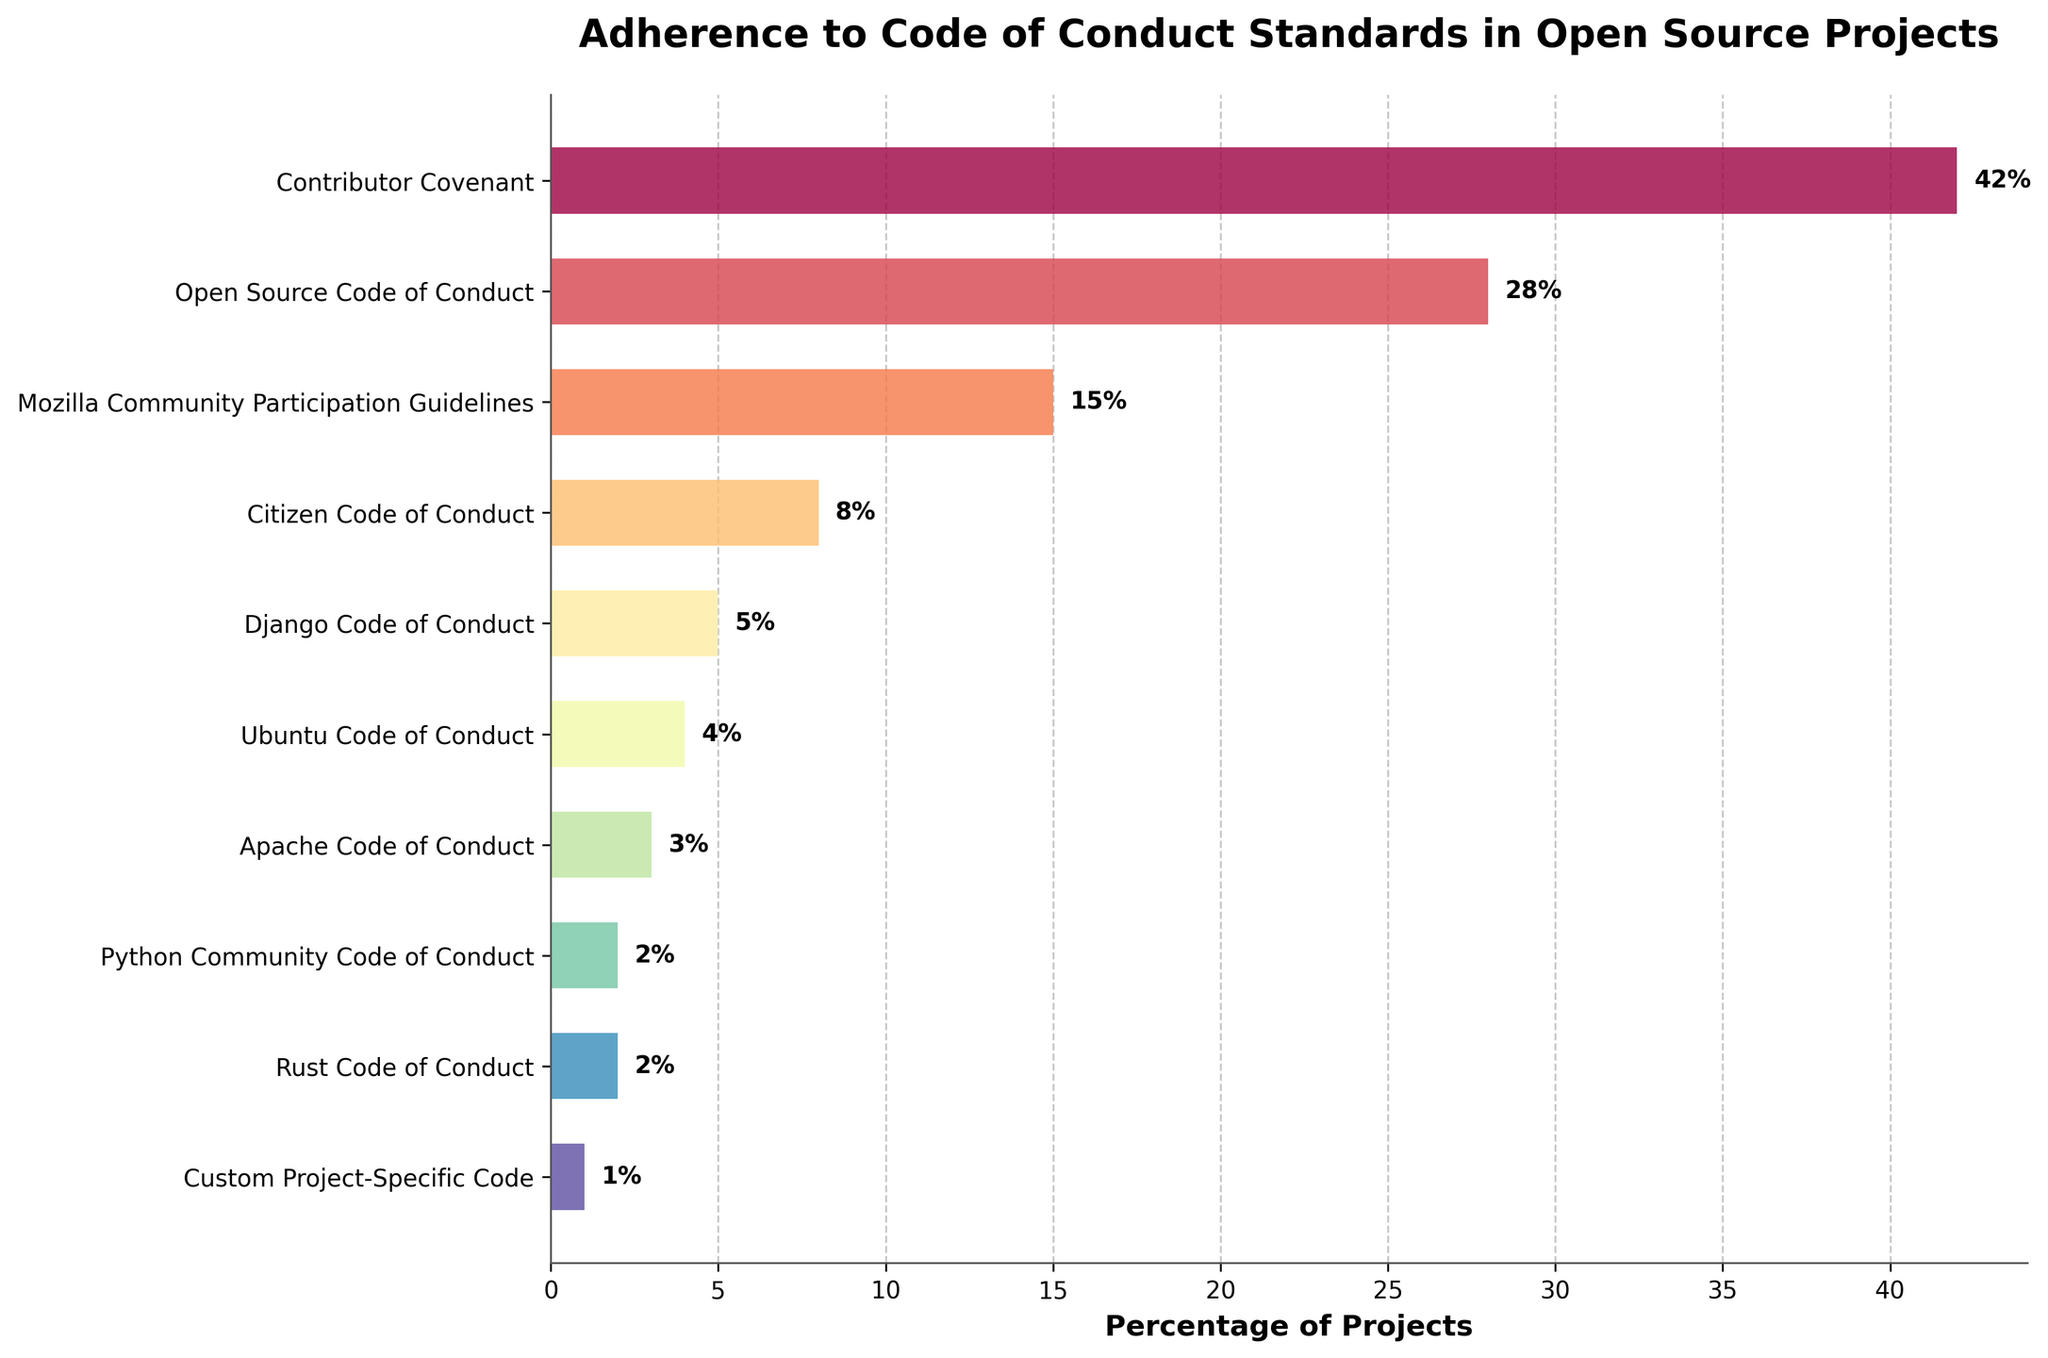Which Code of Conduct standard has the highest percentage of projects adhering to it? Observing the bar chart, the bar labeled "Contributor Covenant" extends the farthest to the right, indicating the largest percentage.
Answer: Contributor Covenant What's the total percentage of projects following either the Django Code of Conduct or the Ubuntu Code of Conduct? Summing the percentages for Django Code of Conduct (5%) and Ubuntu Code of Conduct (4%) gives 5 + 4 = 9%.
Answer: 9% Which standard has a higher adherence, Mozilla Community Participation Guidelines or Citizen Code of Conduct? Comparing the bars, the bar for Mozilla Community Participation Guidelines is longer than the Citizen Code of Conduct.
Answer: Mozilla Community Participation Guidelines How much lesser is the adherence percentage for Open Source Code of Conduct compared to Contributor Covenant? Subtracting the percentage for Open Source Code of Conduct (28%) from that for Contributor Covenant (42%) gives 42 - 28 = 14%.
Answer: 14% Identify the standards that have an adherence percentage of 2% each. Observing the bars, both the Python Community Code of Conduct and the Rust Code of Conduct have their bars ending at 2%.
Answer: Python Community Code of Conduct, Rust Code of Conduct What's the difference between the highest and lowest adherence percentages? Subtracting the lowest (Custom Project-Specific Code, 1%) from the highest (Contributor Covenant, 42%) gives 42 - 1 = 41%.
Answer: 41% What percentage of projects adhere to the Apache Code of Conduct and the Citizen Code of Conduct combined? Summing the percentages for Apache Code of Conduct (3%) and Citizen Code of Conduct (8%) gives 3 + 8 = 11%.
Answer: 11% Which standards have an adherence rate less than 5%? Observing the bars, the standards are Ubuntu Code of Conduct (4%), Apache Code of Conduct (3%), Python Community Code of Conduct (2%), Rust Code of Conduct (2%), and Custom Project-Specific Code (1%).
Answer: Ubuntu Code of Conduct, Apache Code of Conduct, Python Community Code of Conduct, Rust Code of Conduct, Custom Project-Specific Code What is the adherence percentage for the second most followed Code of Conduct standard? The second longest bar corresponds to the Open Source Code of Conduct, indicating a 28% adherence rate.
Answer: 28% What is the combined adherence percentage of the four least followed standards? Summing the percentages for Custom Project-Specific Code (1%), Python Community Code of Conduct (2%), Rust Code of Conduct (2%), and Apache Code of Conduct (3%) gives 1 + 2 + 2 + 3 = 8%.
Answer: 8% 